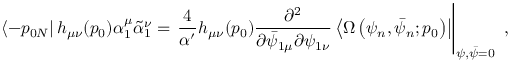<formula> <loc_0><loc_0><loc_500><loc_500>\left \langle - p _ { 0 N } \right | h _ { \mu \nu } ( p _ { 0 } ) \alpha _ { 1 } ^ { \mu } \tilde { \alpha } _ { 1 } ^ { \nu } = \frac { 4 } { \alpha ^ { \prime } } h _ { \mu \nu } ( p _ { 0 } ) \frac { \partial ^ { 2 } } { \partial \bar { \psi } _ { 1 \mu } \partial \psi _ { 1 \nu } } \left \langle \Omega \left ( \psi _ { n } , \bar { \psi } _ { n } ; p _ { 0 } \right ) \right | \right | _ { \psi , \bar { \psi } = 0 } ,</formula> 